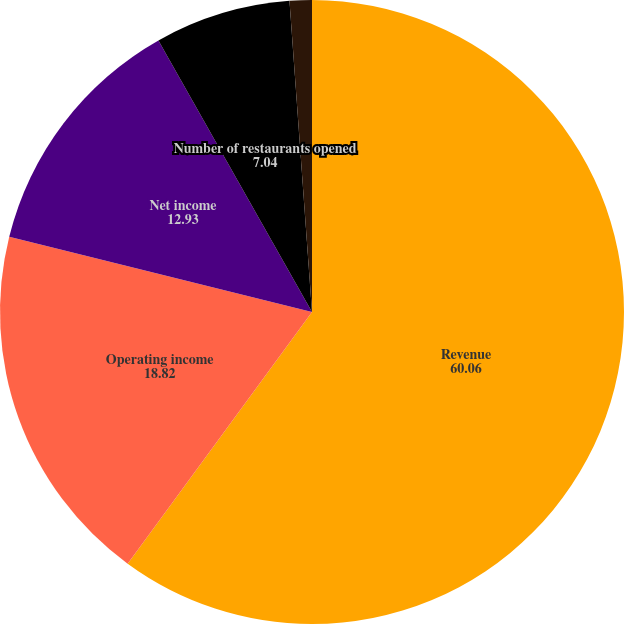<chart> <loc_0><loc_0><loc_500><loc_500><pie_chart><fcel>Revenue<fcel>Operating income<fcel>Net income<fcel>Number of restaurants opened<fcel>Comparable restaurant sales<nl><fcel>60.06%<fcel>18.82%<fcel>12.93%<fcel>7.04%<fcel>1.15%<nl></chart> 